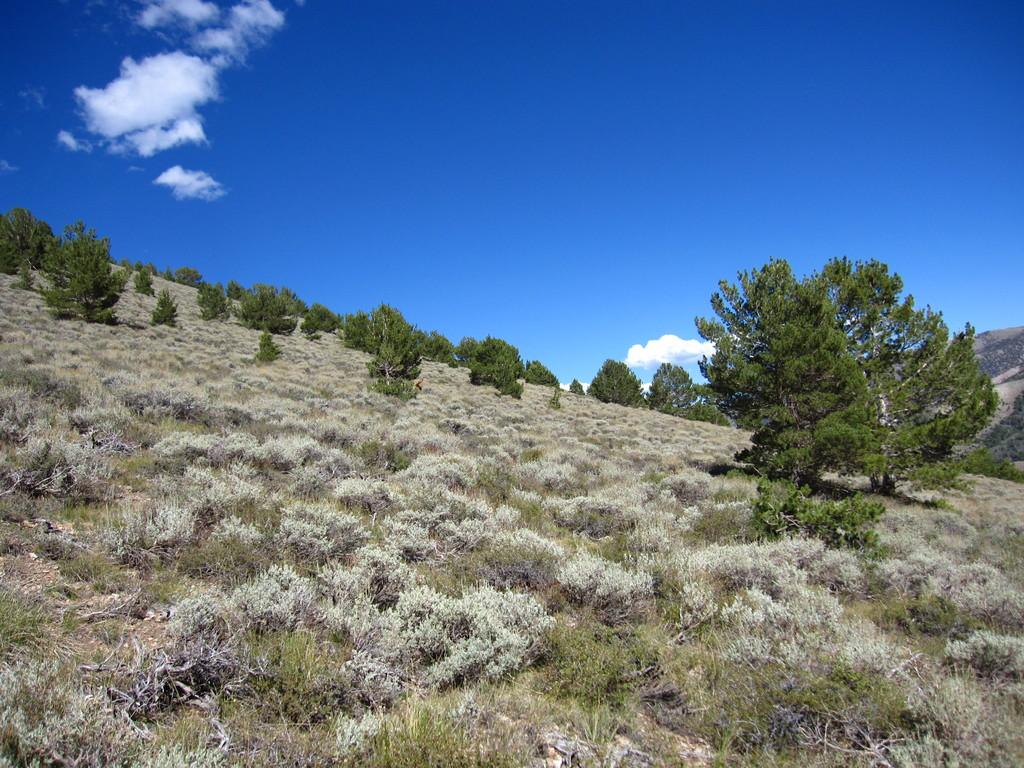What type of surface is visible in the image? There is a hill surface in the image. What covers the hill surface? The hill surface is covered with grass plants. Are there any other types of plants in the image? Yes, there are other plants in the image. What can be seen in the background of the image? The sky is visible in the background of the image. What is present in the sky? Clouds are present in the sky. What type of ghost can be seen interacting with the locket in the image? There is no ghost or locket present in the image; it features a hill surface covered with grass plants, other plants, a tree, and a sky with clouds. What substance is being used to create the clouds in the image? The clouds in the image are a natural atmospheric phenomenon and are not created by any substance. 